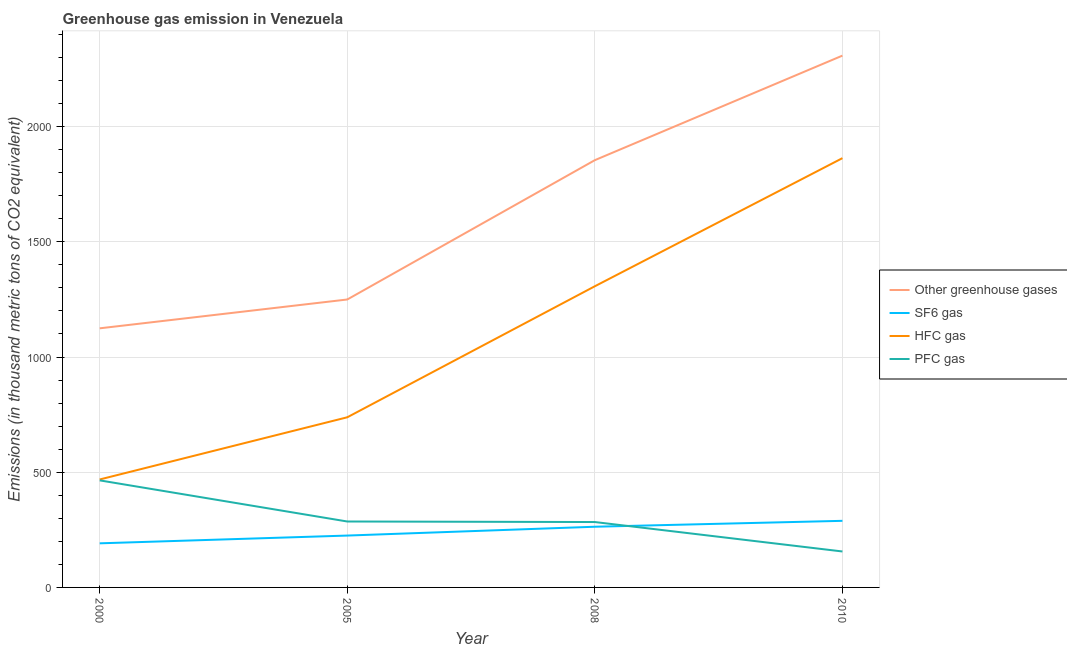What is the emission of hfc gas in 2010?
Offer a terse response. 1863. Across all years, what is the maximum emission of greenhouse gases?
Give a very brief answer. 2308. Across all years, what is the minimum emission of greenhouse gases?
Make the answer very short. 1124.5. What is the total emission of greenhouse gases in the graph?
Give a very brief answer. 6536.4. What is the difference between the emission of hfc gas in 2005 and that in 2008?
Keep it short and to the point. -568.7. What is the difference between the emission of hfc gas in 2000 and the emission of greenhouse gases in 2005?
Offer a terse response. -781.1. What is the average emission of sf6 gas per year?
Your answer should be compact. 242.22. In the year 2010, what is the difference between the emission of greenhouse gases and emission of hfc gas?
Provide a succinct answer. 445. In how many years, is the emission of hfc gas greater than 300 thousand metric tons?
Keep it short and to the point. 4. What is the ratio of the emission of pfc gas in 2000 to that in 2005?
Make the answer very short. 1.62. Is the emission of greenhouse gases in 2005 less than that in 2010?
Your response must be concise. Yes. What is the difference between the highest and the second highest emission of greenhouse gases?
Give a very brief answer. 453.7. What is the difference between the highest and the lowest emission of pfc gas?
Make the answer very short. 308.6. Is it the case that in every year, the sum of the emission of greenhouse gases and emission of sf6 gas is greater than the emission of hfc gas?
Provide a short and direct response. Yes. Is the emission of pfc gas strictly greater than the emission of greenhouse gases over the years?
Provide a succinct answer. No. How many lines are there?
Provide a short and direct response. 4. How many years are there in the graph?
Your answer should be compact. 4. Are the values on the major ticks of Y-axis written in scientific E-notation?
Your answer should be very brief. No. Does the graph contain grids?
Your answer should be very brief. Yes. Where does the legend appear in the graph?
Keep it short and to the point. Center right. How many legend labels are there?
Make the answer very short. 4. How are the legend labels stacked?
Your response must be concise. Vertical. What is the title of the graph?
Give a very brief answer. Greenhouse gas emission in Venezuela. What is the label or title of the X-axis?
Provide a succinct answer. Year. What is the label or title of the Y-axis?
Provide a short and direct response. Emissions (in thousand metric tons of CO2 equivalent). What is the Emissions (in thousand metric tons of CO2 equivalent) of Other greenhouse gases in 2000?
Keep it short and to the point. 1124.5. What is the Emissions (in thousand metric tons of CO2 equivalent) of SF6 gas in 2000?
Offer a very short reply. 191.4. What is the Emissions (in thousand metric tons of CO2 equivalent) in HFC gas in 2000?
Offer a very short reply. 468.5. What is the Emissions (in thousand metric tons of CO2 equivalent) of PFC gas in 2000?
Give a very brief answer. 464.6. What is the Emissions (in thousand metric tons of CO2 equivalent) in Other greenhouse gases in 2005?
Make the answer very short. 1249.6. What is the Emissions (in thousand metric tons of CO2 equivalent) of SF6 gas in 2005?
Offer a very short reply. 225.1. What is the Emissions (in thousand metric tons of CO2 equivalent) of HFC gas in 2005?
Provide a succinct answer. 738.4. What is the Emissions (in thousand metric tons of CO2 equivalent) in PFC gas in 2005?
Make the answer very short. 286.1. What is the Emissions (in thousand metric tons of CO2 equivalent) of Other greenhouse gases in 2008?
Your response must be concise. 1854.3. What is the Emissions (in thousand metric tons of CO2 equivalent) of SF6 gas in 2008?
Give a very brief answer. 263.4. What is the Emissions (in thousand metric tons of CO2 equivalent) in HFC gas in 2008?
Make the answer very short. 1307.1. What is the Emissions (in thousand metric tons of CO2 equivalent) of PFC gas in 2008?
Give a very brief answer. 283.8. What is the Emissions (in thousand metric tons of CO2 equivalent) of Other greenhouse gases in 2010?
Provide a short and direct response. 2308. What is the Emissions (in thousand metric tons of CO2 equivalent) in SF6 gas in 2010?
Keep it short and to the point. 289. What is the Emissions (in thousand metric tons of CO2 equivalent) of HFC gas in 2010?
Provide a succinct answer. 1863. What is the Emissions (in thousand metric tons of CO2 equivalent) of PFC gas in 2010?
Keep it short and to the point. 156. Across all years, what is the maximum Emissions (in thousand metric tons of CO2 equivalent) in Other greenhouse gases?
Offer a terse response. 2308. Across all years, what is the maximum Emissions (in thousand metric tons of CO2 equivalent) in SF6 gas?
Ensure brevity in your answer.  289. Across all years, what is the maximum Emissions (in thousand metric tons of CO2 equivalent) in HFC gas?
Offer a terse response. 1863. Across all years, what is the maximum Emissions (in thousand metric tons of CO2 equivalent) of PFC gas?
Keep it short and to the point. 464.6. Across all years, what is the minimum Emissions (in thousand metric tons of CO2 equivalent) in Other greenhouse gases?
Your response must be concise. 1124.5. Across all years, what is the minimum Emissions (in thousand metric tons of CO2 equivalent) of SF6 gas?
Ensure brevity in your answer.  191.4. Across all years, what is the minimum Emissions (in thousand metric tons of CO2 equivalent) in HFC gas?
Keep it short and to the point. 468.5. Across all years, what is the minimum Emissions (in thousand metric tons of CO2 equivalent) of PFC gas?
Offer a terse response. 156. What is the total Emissions (in thousand metric tons of CO2 equivalent) in Other greenhouse gases in the graph?
Provide a short and direct response. 6536.4. What is the total Emissions (in thousand metric tons of CO2 equivalent) in SF6 gas in the graph?
Offer a terse response. 968.9. What is the total Emissions (in thousand metric tons of CO2 equivalent) in HFC gas in the graph?
Offer a terse response. 4377. What is the total Emissions (in thousand metric tons of CO2 equivalent) of PFC gas in the graph?
Your answer should be compact. 1190.5. What is the difference between the Emissions (in thousand metric tons of CO2 equivalent) of Other greenhouse gases in 2000 and that in 2005?
Provide a short and direct response. -125.1. What is the difference between the Emissions (in thousand metric tons of CO2 equivalent) of SF6 gas in 2000 and that in 2005?
Offer a very short reply. -33.7. What is the difference between the Emissions (in thousand metric tons of CO2 equivalent) of HFC gas in 2000 and that in 2005?
Provide a short and direct response. -269.9. What is the difference between the Emissions (in thousand metric tons of CO2 equivalent) in PFC gas in 2000 and that in 2005?
Keep it short and to the point. 178.5. What is the difference between the Emissions (in thousand metric tons of CO2 equivalent) in Other greenhouse gases in 2000 and that in 2008?
Make the answer very short. -729.8. What is the difference between the Emissions (in thousand metric tons of CO2 equivalent) of SF6 gas in 2000 and that in 2008?
Your answer should be very brief. -72. What is the difference between the Emissions (in thousand metric tons of CO2 equivalent) of HFC gas in 2000 and that in 2008?
Ensure brevity in your answer.  -838.6. What is the difference between the Emissions (in thousand metric tons of CO2 equivalent) in PFC gas in 2000 and that in 2008?
Offer a very short reply. 180.8. What is the difference between the Emissions (in thousand metric tons of CO2 equivalent) in Other greenhouse gases in 2000 and that in 2010?
Offer a very short reply. -1183.5. What is the difference between the Emissions (in thousand metric tons of CO2 equivalent) in SF6 gas in 2000 and that in 2010?
Your response must be concise. -97.6. What is the difference between the Emissions (in thousand metric tons of CO2 equivalent) of HFC gas in 2000 and that in 2010?
Your answer should be compact. -1394.5. What is the difference between the Emissions (in thousand metric tons of CO2 equivalent) in PFC gas in 2000 and that in 2010?
Offer a very short reply. 308.6. What is the difference between the Emissions (in thousand metric tons of CO2 equivalent) of Other greenhouse gases in 2005 and that in 2008?
Your answer should be very brief. -604.7. What is the difference between the Emissions (in thousand metric tons of CO2 equivalent) of SF6 gas in 2005 and that in 2008?
Keep it short and to the point. -38.3. What is the difference between the Emissions (in thousand metric tons of CO2 equivalent) of HFC gas in 2005 and that in 2008?
Give a very brief answer. -568.7. What is the difference between the Emissions (in thousand metric tons of CO2 equivalent) in PFC gas in 2005 and that in 2008?
Your answer should be very brief. 2.3. What is the difference between the Emissions (in thousand metric tons of CO2 equivalent) of Other greenhouse gases in 2005 and that in 2010?
Provide a succinct answer. -1058.4. What is the difference between the Emissions (in thousand metric tons of CO2 equivalent) in SF6 gas in 2005 and that in 2010?
Offer a very short reply. -63.9. What is the difference between the Emissions (in thousand metric tons of CO2 equivalent) of HFC gas in 2005 and that in 2010?
Give a very brief answer. -1124.6. What is the difference between the Emissions (in thousand metric tons of CO2 equivalent) of PFC gas in 2005 and that in 2010?
Provide a short and direct response. 130.1. What is the difference between the Emissions (in thousand metric tons of CO2 equivalent) of Other greenhouse gases in 2008 and that in 2010?
Ensure brevity in your answer.  -453.7. What is the difference between the Emissions (in thousand metric tons of CO2 equivalent) of SF6 gas in 2008 and that in 2010?
Your response must be concise. -25.6. What is the difference between the Emissions (in thousand metric tons of CO2 equivalent) of HFC gas in 2008 and that in 2010?
Provide a succinct answer. -555.9. What is the difference between the Emissions (in thousand metric tons of CO2 equivalent) of PFC gas in 2008 and that in 2010?
Offer a very short reply. 127.8. What is the difference between the Emissions (in thousand metric tons of CO2 equivalent) in Other greenhouse gases in 2000 and the Emissions (in thousand metric tons of CO2 equivalent) in SF6 gas in 2005?
Provide a short and direct response. 899.4. What is the difference between the Emissions (in thousand metric tons of CO2 equivalent) in Other greenhouse gases in 2000 and the Emissions (in thousand metric tons of CO2 equivalent) in HFC gas in 2005?
Your answer should be compact. 386.1. What is the difference between the Emissions (in thousand metric tons of CO2 equivalent) in Other greenhouse gases in 2000 and the Emissions (in thousand metric tons of CO2 equivalent) in PFC gas in 2005?
Ensure brevity in your answer.  838.4. What is the difference between the Emissions (in thousand metric tons of CO2 equivalent) of SF6 gas in 2000 and the Emissions (in thousand metric tons of CO2 equivalent) of HFC gas in 2005?
Ensure brevity in your answer.  -547. What is the difference between the Emissions (in thousand metric tons of CO2 equivalent) of SF6 gas in 2000 and the Emissions (in thousand metric tons of CO2 equivalent) of PFC gas in 2005?
Offer a terse response. -94.7. What is the difference between the Emissions (in thousand metric tons of CO2 equivalent) in HFC gas in 2000 and the Emissions (in thousand metric tons of CO2 equivalent) in PFC gas in 2005?
Keep it short and to the point. 182.4. What is the difference between the Emissions (in thousand metric tons of CO2 equivalent) in Other greenhouse gases in 2000 and the Emissions (in thousand metric tons of CO2 equivalent) in SF6 gas in 2008?
Your answer should be very brief. 861.1. What is the difference between the Emissions (in thousand metric tons of CO2 equivalent) in Other greenhouse gases in 2000 and the Emissions (in thousand metric tons of CO2 equivalent) in HFC gas in 2008?
Offer a terse response. -182.6. What is the difference between the Emissions (in thousand metric tons of CO2 equivalent) of Other greenhouse gases in 2000 and the Emissions (in thousand metric tons of CO2 equivalent) of PFC gas in 2008?
Your answer should be compact. 840.7. What is the difference between the Emissions (in thousand metric tons of CO2 equivalent) of SF6 gas in 2000 and the Emissions (in thousand metric tons of CO2 equivalent) of HFC gas in 2008?
Your answer should be compact. -1115.7. What is the difference between the Emissions (in thousand metric tons of CO2 equivalent) in SF6 gas in 2000 and the Emissions (in thousand metric tons of CO2 equivalent) in PFC gas in 2008?
Provide a short and direct response. -92.4. What is the difference between the Emissions (in thousand metric tons of CO2 equivalent) of HFC gas in 2000 and the Emissions (in thousand metric tons of CO2 equivalent) of PFC gas in 2008?
Give a very brief answer. 184.7. What is the difference between the Emissions (in thousand metric tons of CO2 equivalent) of Other greenhouse gases in 2000 and the Emissions (in thousand metric tons of CO2 equivalent) of SF6 gas in 2010?
Offer a very short reply. 835.5. What is the difference between the Emissions (in thousand metric tons of CO2 equivalent) in Other greenhouse gases in 2000 and the Emissions (in thousand metric tons of CO2 equivalent) in HFC gas in 2010?
Ensure brevity in your answer.  -738.5. What is the difference between the Emissions (in thousand metric tons of CO2 equivalent) of Other greenhouse gases in 2000 and the Emissions (in thousand metric tons of CO2 equivalent) of PFC gas in 2010?
Provide a short and direct response. 968.5. What is the difference between the Emissions (in thousand metric tons of CO2 equivalent) in SF6 gas in 2000 and the Emissions (in thousand metric tons of CO2 equivalent) in HFC gas in 2010?
Your answer should be very brief. -1671.6. What is the difference between the Emissions (in thousand metric tons of CO2 equivalent) in SF6 gas in 2000 and the Emissions (in thousand metric tons of CO2 equivalent) in PFC gas in 2010?
Keep it short and to the point. 35.4. What is the difference between the Emissions (in thousand metric tons of CO2 equivalent) of HFC gas in 2000 and the Emissions (in thousand metric tons of CO2 equivalent) of PFC gas in 2010?
Provide a succinct answer. 312.5. What is the difference between the Emissions (in thousand metric tons of CO2 equivalent) of Other greenhouse gases in 2005 and the Emissions (in thousand metric tons of CO2 equivalent) of SF6 gas in 2008?
Make the answer very short. 986.2. What is the difference between the Emissions (in thousand metric tons of CO2 equivalent) in Other greenhouse gases in 2005 and the Emissions (in thousand metric tons of CO2 equivalent) in HFC gas in 2008?
Ensure brevity in your answer.  -57.5. What is the difference between the Emissions (in thousand metric tons of CO2 equivalent) in Other greenhouse gases in 2005 and the Emissions (in thousand metric tons of CO2 equivalent) in PFC gas in 2008?
Ensure brevity in your answer.  965.8. What is the difference between the Emissions (in thousand metric tons of CO2 equivalent) of SF6 gas in 2005 and the Emissions (in thousand metric tons of CO2 equivalent) of HFC gas in 2008?
Ensure brevity in your answer.  -1082. What is the difference between the Emissions (in thousand metric tons of CO2 equivalent) of SF6 gas in 2005 and the Emissions (in thousand metric tons of CO2 equivalent) of PFC gas in 2008?
Give a very brief answer. -58.7. What is the difference between the Emissions (in thousand metric tons of CO2 equivalent) in HFC gas in 2005 and the Emissions (in thousand metric tons of CO2 equivalent) in PFC gas in 2008?
Offer a terse response. 454.6. What is the difference between the Emissions (in thousand metric tons of CO2 equivalent) of Other greenhouse gases in 2005 and the Emissions (in thousand metric tons of CO2 equivalent) of SF6 gas in 2010?
Offer a very short reply. 960.6. What is the difference between the Emissions (in thousand metric tons of CO2 equivalent) of Other greenhouse gases in 2005 and the Emissions (in thousand metric tons of CO2 equivalent) of HFC gas in 2010?
Provide a short and direct response. -613.4. What is the difference between the Emissions (in thousand metric tons of CO2 equivalent) of Other greenhouse gases in 2005 and the Emissions (in thousand metric tons of CO2 equivalent) of PFC gas in 2010?
Keep it short and to the point. 1093.6. What is the difference between the Emissions (in thousand metric tons of CO2 equivalent) in SF6 gas in 2005 and the Emissions (in thousand metric tons of CO2 equivalent) in HFC gas in 2010?
Make the answer very short. -1637.9. What is the difference between the Emissions (in thousand metric tons of CO2 equivalent) in SF6 gas in 2005 and the Emissions (in thousand metric tons of CO2 equivalent) in PFC gas in 2010?
Your response must be concise. 69.1. What is the difference between the Emissions (in thousand metric tons of CO2 equivalent) of HFC gas in 2005 and the Emissions (in thousand metric tons of CO2 equivalent) of PFC gas in 2010?
Ensure brevity in your answer.  582.4. What is the difference between the Emissions (in thousand metric tons of CO2 equivalent) of Other greenhouse gases in 2008 and the Emissions (in thousand metric tons of CO2 equivalent) of SF6 gas in 2010?
Make the answer very short. 1565.3. What is the difference between the Emissions (in thousand metric tons of CO2 equivalent) in Other greenhouse gases in 2008 and the Emissions (in thousand metric tons of CO2 equivalent) in PFC gas in 2010?
Your response must be concise. 1698.3. What is the difference between the Emissions (in thousand metric tons of CO2 equivalent) in SF6 gas in 2008 and the Emissions (in thousand metric tons of CO2 equivalent) in HFC gas in 2010?
Your answer should be compact. -1599.6. What is the difference between the Emissions (in thousand metric tons of CO2 equivalent) in SF6 gas in 2008 and the Emissions (in thousand metric tons of CO2 equivalent) in PFC gas in 2010?
Ensure brevity in your answer.  107.4. What is the difference between the Emissions (in thousand metric tons of CO2 equivalent) of HFC gas in 2008 and the Emissions (in thousand metric tons of CO2 equivalent) of PFC gas in 2010?
Ensure brevity in your answer.  1151.1. What is the average Emissions (in thousand metric tons of CO2 equivalent) of Other greenhouse gases per year?
Your answer should be very brief. 1634.1. What is the average Emissions (in thousand metric tons of CO2 equivalent) in SF6 gas per year?
Your answer should be compact. 242.22. What is the average Emissions (in thousand metric tons of CO2 equivalent) of HFC gas per year?
Ensure brevity in your answer.  1094.25. What is the average Emissions (in thousand metric tons of CO2 equivalent) of PFC gas per year?
Ensure brevity in your answer.  297.62. In the year 2000, what is the difference between the Emissions (in thousand metric tons of CO2 equivalent) of Other greenhouse gases and Emissions (in thousand metric tons of CO2 equivalent) of SF6 gas?
Your response must be concise. 933.1. In the year 2000, what is the difference between the Emissions (in thousand metric tons of CO2 equivalent) of Other greenhouse gases and Emissions (in thousand metric tons of CO2 equivalent) of HFC gas?
Your response must be concise. 656. In the year 2000, what is the difference between the Emissions (in thousand metric tons of CO2 equivalent) of Other greenhouse gases and Emissions (in thousand metric tons of CO2 equivalent) of PFC gas?
Your answer should be very brief. 659.9. In the year 2000, what is the difference between the Emissions (in thousand metric tons of CO2 equivalent) of SF6 gas and Emissions (in thousand metric tons of CO2 equivalent) of HFC gas?
Provide a succinct answer. -277.1. In the year 2000, what is the difference between the Emissions (in thousand metric tons of CO2 equivalent) in SF6 gas and Emissions (in thousand metric tons of CO2 equivalent) in PFC gas?
Keep it short and to the point. -273.2. In the year 2005, what is the difference between the Emissions (in thousand metric tons of CO2 equivalent) of Other greenhouse gases and Emissions (in thousand metric tons of CO2 equivalent) of SF6 gas?
Your answer should be very brief. 1024.5. In the year 2005, what is the difference between the Emissions (in thousand metric tons of CO2 equivalent) of Other greenhouse gases and Emissions (in thousand metric tons of CO2 equivalent) of HFC gas?
Your response must be concise. 511.2. In the year 2005, what is the difference between the Emissions (in thousand metric tons of CO2 equivalent) in Other greenhouse gases and Emissions (in thousand metric tons of CO2 equivalent) in PFC gas?
Your response must be concise. 963.5. In the year 2005, what is the difference between the Emissions (in thousand metric tons of CO2 equivalent) of SF6 gas and Emissions (in thousand metric tons of CO2 equivalent) of HFC gas?
Your answer should be compact. -513.3. In the year 2005, what is the difference between the Emissions (in thousand metric tons of CO2 equivalent) in SF6 gas and Emissions (in thousand metric tons of CO2 equivalent) in PFC gas?
Make the answer very short. -61. In the year 2005, what is the difference between the Emissions (in thousand metric tons of CO2 equivalent) of HFC gas and Emissions (in thousand metric tons of CO2 equivalent) of PFC gas?
Offer a very short reply. 452.3. In the year 2008, what is the difference between the Emissions (in thousand metric tons of CO2 equivalent) in Other greenhouse gases and Emissions (in thousand metric tons of CO2 equivalent) in SF6 gas?
Keep it short and to the point. 1590.9. In the year 2008, what is the difference between the Emissions (in thousand metric tons of CO2 equivalent) in Other greenhouse gases and Emissions (in thousand metric tons of CO2 equivalent) in HFC gas?
Offer a very short reply. 547.2. In the year 2008, what is the difference between the Emissions (in thousand metric tons of CO2 equivalent) of Other greenhouse gases and Emissions (in thousand metric tons of CO2 equivalent) of PFC gas?
Your response must be concise. 1570.5. In the year 2008, what is the difference between the Emissions (in thousand metric tons of CO2 equivalent) in SF6 gas and Emissions (in thousand metric tons of CO2 equivalent) in HFC gas?
Offer a terse response. -1043.7. In the year 2008, what is the difference between the Emissions (in thousand metric tons of CO2 equivalent) in SF6 gas and Emissions (in thousand metric tons of CO2 equivalent) in PFC gas?
Provide a succinct answer. -20.4. In the year 2008, what is the difference between the Emissions (in thousand metric tons of CO2 equivalent) of HFC gas and Emissions (in thousand metric tons of CO2 equivalent) of PFC gas?
Your answer should be compact. 1023.3. In the year 2010, what is the difference between the Emissions (in thousand metric tons of CO2 equivalent) in Other greenhouse gases and Emissions (in thousand metric tons of CO2 equivalent) in SF6 gas?
Keep it short and to the point. 2019. In the year 2010, what is the difference between the Emissions (in thousand metric tons of CO2 equivalent) of Other greenhouse gases and Emissions (in thousand metric tons of CO2 equivalent) of HFC gas?
Offer a very short reply. 445. In the year 2010, what is the difference between the Emissions (in thousand metric tons of CO2 equivalent) in Other greenhouse gases and Emissions (in thousand metric tons of CO2 equivalent) in PFC gas?
Keep it short and to the point. 2152. In the year 2010, what is the difference between the Emissions (in thousand metric tons of CO2 equivalent) in SF6 gas and Emissions (in thousand metric tons of CO2 equivalent) in HFC gas?
Make the answer very short. -1574. In the year 2010, what is the difference between the Emissions (in thousand metric tons of CO2 equivalent) in SF6 gas and Emissions (in thousand metric tons of CO2 equivalent) in PFC gas?
Your response must be concise. 133. In the year 2010, what is the difference between the Emissions (in thousand metric tons of CO2 equivalent) of HFC gas and Emissions (in thousand metric tons of CO2 equivalent) of PFC gas?
Provide a short and direct response. 1707. What is the ratio of the Emissions (in thousand metric tons of CO2 equivalent) in Other greenhouse gases in 2000 to that in 2005?
Make the answer very short. 0.9. What is the ratio of the Emissions (in thousand metric tons of CO2 equivalent) of SF6 gas in 2000 to that in 2005?
Your answer should be compact. 0.85. What is the ratio of the Emissions (in thousand metric tons of CO2 equivalent) in HFC gas in 2000 to that in 2005?
Offer a terse response. 0.63. What is the ratio of the Emissions (in thousand metric tons of CO2 equivalent) in PFC gas in 2000 to that in 2005?
Offer a very short reply. 1.62. What is the ratio of the Emissions (in thousand metric tons of CO2 equivalent) in Other greenhouse gases in 2000 to that in 2008?
Make the answer very short. 0.61. What is the ratio of the Emissions (in thousand metric tons of CO2 equivalent) of SF6 gas in 2000 to that in 2008?
Keep it short and to the point. 0.73. What is the ratio of the Emissions (in thousand metric tons of CO2 equivalent) of HFC gas in 2000 to that in 2008?
Provide a short and direct response. 0.36. What is the ratio of the Emissions (in thousand metric tons of CO2 equivalent) in PFC gas in 2000 to that in 2008?
Ensure brevity in your answer.  1.64. What is the ratio of the Emissions (in thousand metric tons of CO2 equivalent) in Other greenhouse gases in 2000 to that in 2010?
Give a very brief answer. 0.49. What is the ratio of the Emissions (in thousand metric tons of CO2 equivalent) in SF6 gas in 2000 to that in 2010?
Offer a very short reply. 0.66. What is the ratio of the Emissions (in thousand metric tons of CO2 equivalent) of HFC gas in 2000 to that in 2010?
Offer a very short reply. 0.25. What is the ratio of the Emissions (in thousand metric tons of CO2 equivalent) in PFC gas in 2000 to that in 2010?
Offer a very short reply. 2.98. What is the ratio of the Emissions (in thousand metric tons of CO2 equivalent) in Other greenhouse gases in 2005 to that in 2008?
Give a very brief answer. 0.67. What is the ratio of the Emissions (in thousand metric tons of CO2 equivalent) of SF6 gas in 2005 to that in 2008?
Provide a short and direct response. 0.85. What is the ratio of the Emissions (in thousand metric tons of CO2 equivalent) of HFC gas in 2005 to that in 2008?
Make the answer very short. 0.56. What is the ratio of the Emissions (in thousand metric tons of CO2 equivalent) in PFC gas in 2005 to that in 2008?
Offer a very short reply. 1.01. What is the ratio of the Emissions (in thousand metric tons of CO2 equivalent) of Other greenhouse gases in 2005 to that in 2010?
Make the answer very short. 0.54. What is the ratio of the Emissions (in thousand metric tons of CO2 equivalent) of SF6 gas in 2005 to that in 2010?
Provide a short and direct response. 0.78. What is the ratio of the Emissions (in thousand metric tons of CO2 equivalent) in HFC gas in 2005 to that in 2010?
Keep it short and to the point. 0.4. What is the ratio of the Emissions (in thousand metric tons of CO2 equivalent) of PFC gas in 2005 to that in 2010?
Keep it short and to the point. 1.83. What is the ratio of the Emissions (in thousand metric tons of CO2 equivalent) of Other greenhouse gases in 2008 to that in 2010?
Give a very brief answer. 0.8. What is the ratio of the Emissions (in thousand metric tons of CO2 equivalent) of SF6 gas in 2008 to that in 2010?
Provide a short and direct response. 0.91. What is the ratio of the Emissions (in thousand metric tons of CO2 equivalent) in HFC gas in 2008 to that in 2010?
Ensure brevity in your answer.  0.7. What is the ratio of the Emissions (in thousand metric tons of CO2 equivalent) in PFC gas in 2008 to that in 2010?
Ensure brevity in your answer.  1.82. What is the difference between the highest and the second highest Emissions (in thousand metric tons of CO2 equivalent) of Other greenhouse gases?
Provide a succinct answer. 453.7. What is the difference between the highest and the second highest Emissions (in thousand metric tons of CO2 equivalent) of SF6 gas?
Your answer should be compact. 25.6. What is the difference between the highest and the second highest Emissions (in thousand metric tons of CO2 equivalent) in HFC gas?
Ensure brevity in your answer.  555.9. What is the difference between the highest and the second highest Emissions (in thousand metric tons of CO2 equivalent) in PFC gas?
Your response must be concise. 178.5. What is the difference between the highest and the lowest Emissions (in thousand metric tons of CO2 equivalent) of Other greenhouse gases?
Give a very brief answer. 1183.5. What is the difference between the highest and the lowest Emissions (in thousand metric tons of CO2 equivalent) of SF6 gas?
Offer a very short reply. 97.6. What is the difference between the highest and the lowest Emissions (in thousand metric tons of CO2 equivalent) of HFC gas?
Your answer should be compact. 1394.5. What is the difference between the highest and the lowest Emissions (in thousand metric tons of CO2 equivalent) in PFC gas?
Keep it short and to the point. 308.6. 